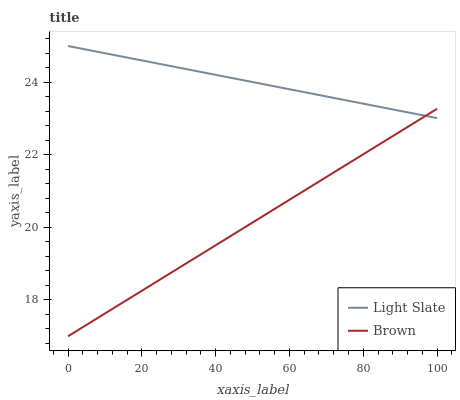Does Brown have the minimum area under the curve?
Answer yes or no. Yes. Does Light Slate have the maximum area under the curve?
Answer yes or no. Yes. Does Brown have the maximum area under the curve?
Answer yes or no. No. Is Brown the smoothest?
Answer yes or no. Yes. Is Light Slate the roughest?
Answer yes or no. Yes. Is Brown the roughest?
Answer yes or no. No. Does Brown have the lowest value?
Answer yes or no. Yes. Does Light Slate have the highest value?
Answer yes or no. Yes. Does Brown have the highest value?
Answer yes or no. No. Does Brown intersect Light Slate?
Answer yes or no. Yes. Is Brown less than Light Slate?
Answer yes or no. No. Is Brown greater than Light Slate?
Answer yes or no. No. 